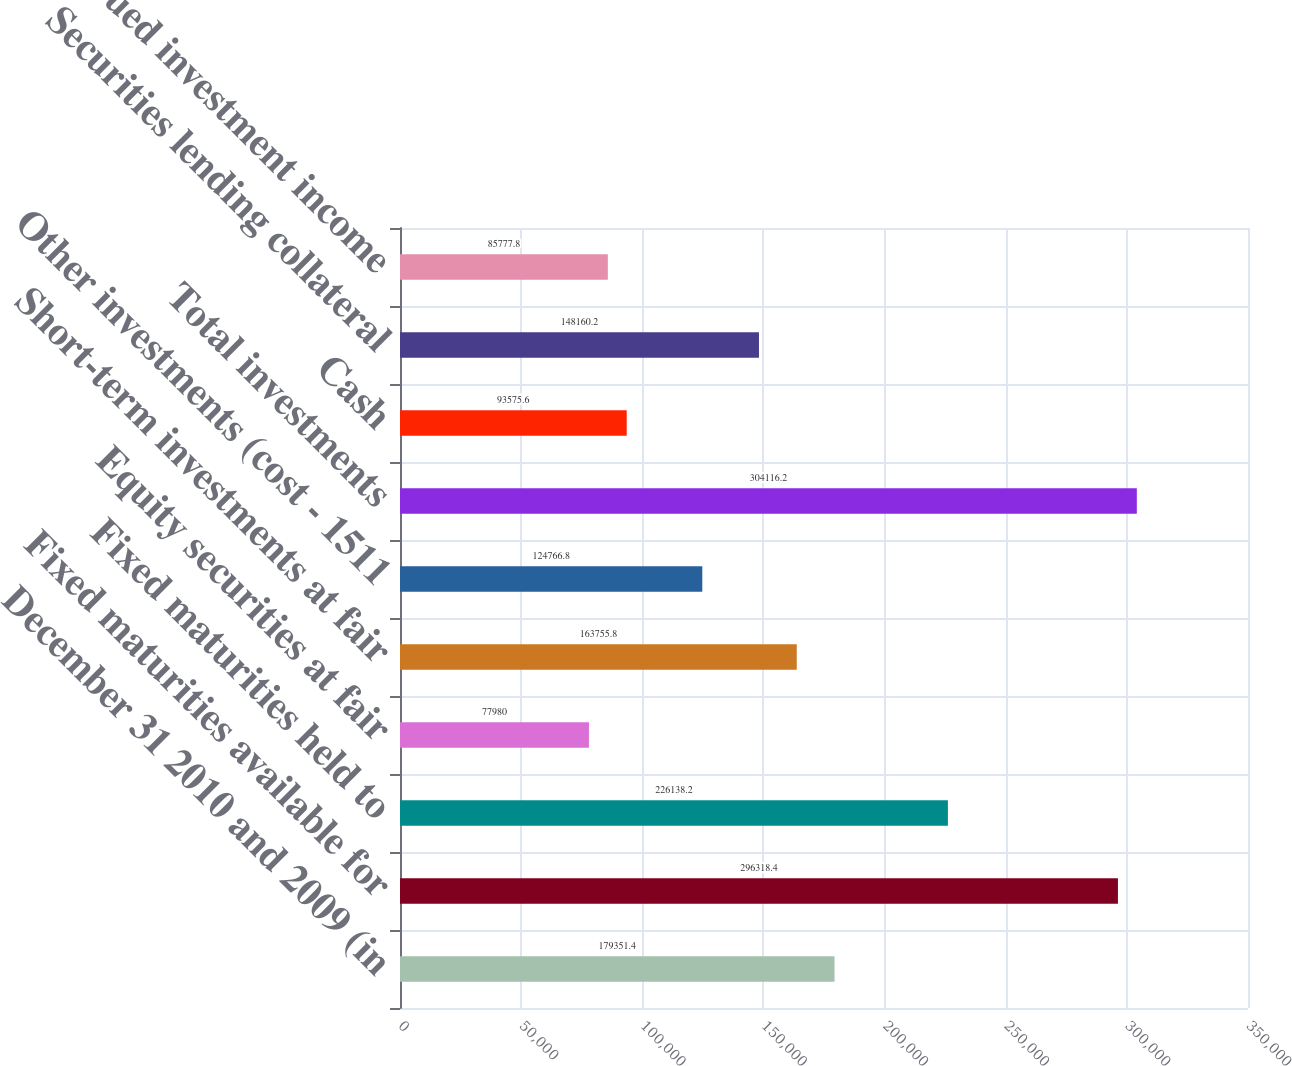Convert chart. <chart><loc_0><loc_0><loc_500><loc_500><bar_chart><fcel>December 31 2010 and 2009 (in<fcel>Fixed maturities available for<fcel>Fixed maturities held to<fcel>Equity securities at fair<fcel>Short-term investments at fair<fcel>Other investments (cost - 1511<fcel>Total investments<fcel>Cash<fcel>Securities lending collateral<fcel>Accrued investment income<nl><fcel>179351<fcel>296318<fcel>226138<fcel>77980<fcel>163756<fcel>124767<fcel>304116<fcel>93575.6<fcel>148160<fcel>85777.8<nl></chart> 